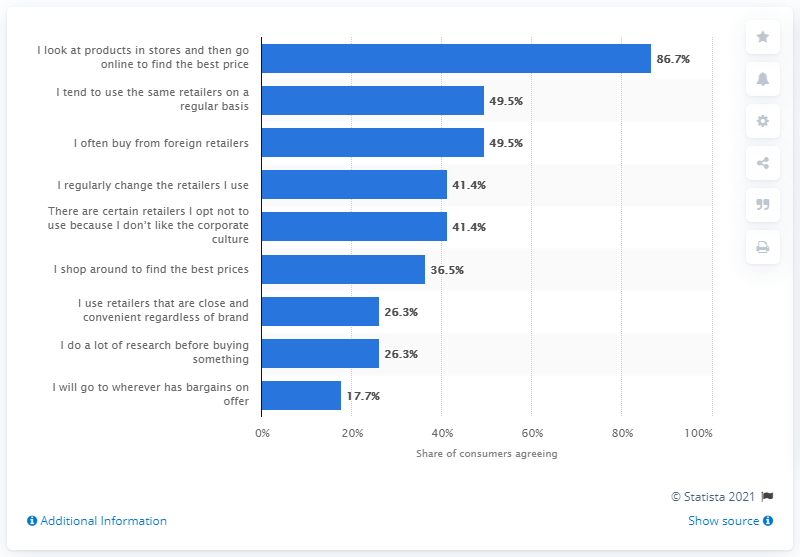List a handful of essential elements in this visual. According to a survey of Irish consumers, 86.7% of respondents admitted to checking products in physical stores but ultimately turning to the internet to find the best price. 